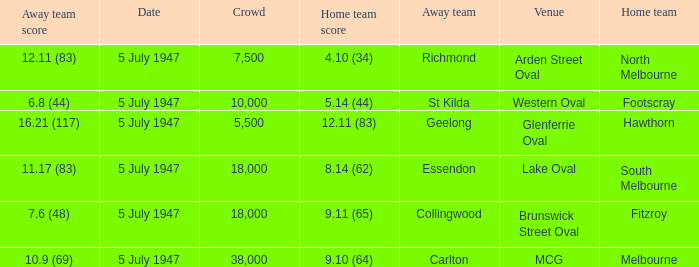Where was the game played where the away team has a score of 7.6 (48)? Brunswick Street Oval. Could you parse the entire table? {'header': ['Away team score', 'Date', 'Crowd', 'Home team score', 'Away team', 'Venue', 'Home team'], 'rows': [['12.11 (83)', '5 July 1947', '7,500', '4.10 (34)', 'Richmond', 'Arden Street Oval', 'North Melbourne'], ['6.8 (44)', '5 July 1947', '10,000', '5.14 (44)', 'St Kilda', 'Western Oval', 'Footscray'], ['16.21 (117)', '5 July 1947', '5,500', '12.11 (83)', 'Geelong', 'Glenferrie Oval', 'Hawthorn'], ['11.17 (83)', '5 July 1947', '18,000', '8.14 (62)', 'Essendon', 'Lake Oval', 'South Melbourne'], ['7.6 (48)', '5 July 1947', '18,000', '9.11 (65)', 'Collingwood', 'Brunswick Street Oval', 'Fitzroy'], ['10.9 (69)', '5 July 1947', '38,000', '9.10 (64)', 'Carlton', 'MCG', 'Melbourne']]} 